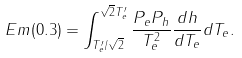Convert formula to latex. <formula><loc_0><loc_0><loc_500><loc_500>E m ( 0 . 3 ) = \int _ { T ^ { \prime } _ { e } / \sqrt { 2 } } ^ { \sqrt { 2 } T ^ { \prime } _ { e } } \frac { P _ { e } P _ { h } } { T _ { e } ^ { 2 } } \frac { d h } { d T _ { e } } d T _ { e } .</formula> 